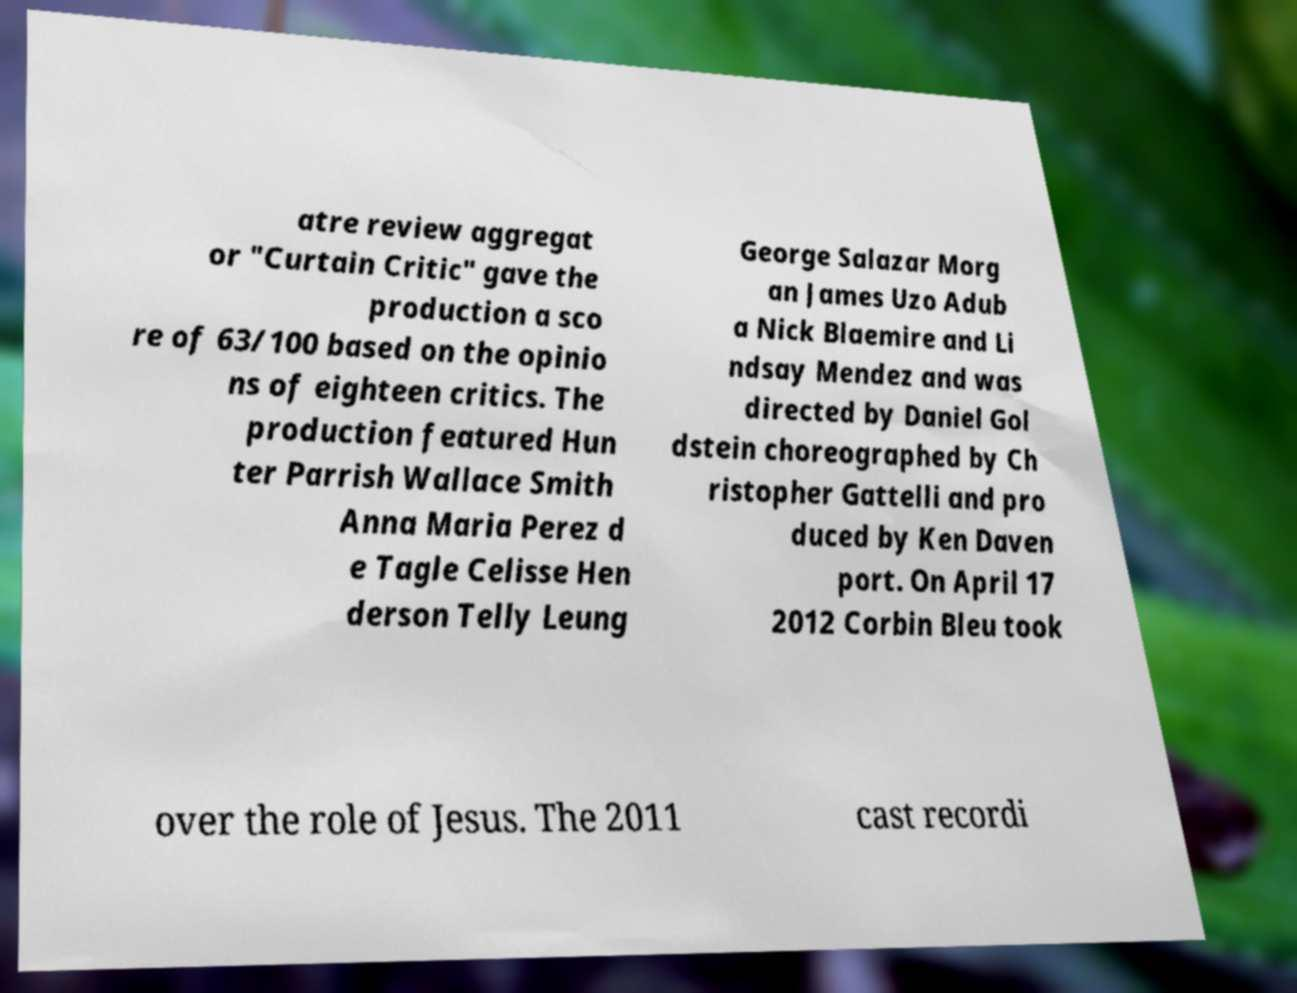Can you read and provide the text displayed in the image?This photo seems to have some interesting text. Can you extract and type it out for me? atre review aggregat or "Curtain Critic" gave the production a sco re of 63/100 based on the opinio ns of eighteen critics. The production featured Hun ter Parrish Wallace Smith Anna Maria Perez d e Tagle Celisse Hen derson Telly Leung George Salazar Morg an James Uzo Adub a Nick Blaemire and Li ndsay Mendez and was directed by Daniel Gol dstein choreographed by Ch ristopher Gattelli and pro duced by Ken Daven port. On April 17 2012 Corbin Bleu took over the role of Jesus. The 2011 cast recordi 